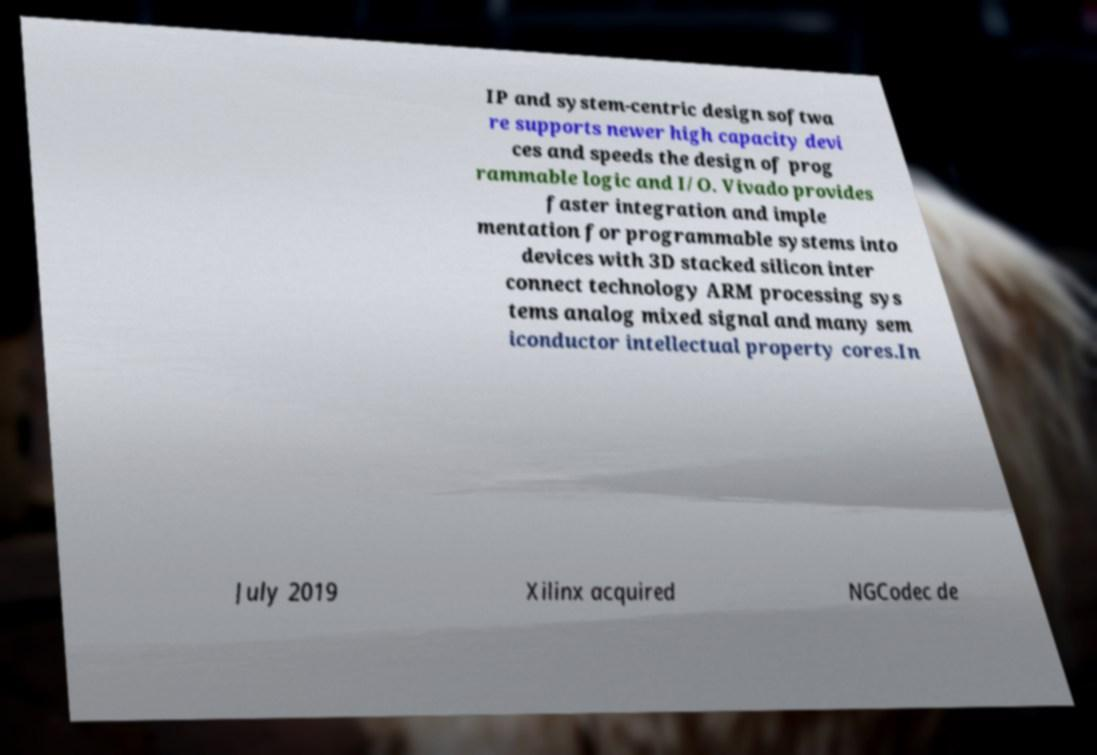Can you read and provide the text displayed in the image?This photo seems to have some interesting text. Can you extract and type it out for me? IP and system-centric design softwa re supports newer high capacity devi ces and speeds the design of prog rammable logic and I/O. Vivado provides faster integration and imple mentation for programmable systems into devices with 3D stacked silicon inter connect technology ARM processing sys tems analog mixed signal and many sem iconductor intellectual property cores.In July 2019 Xilinx acquired NGCodec de 